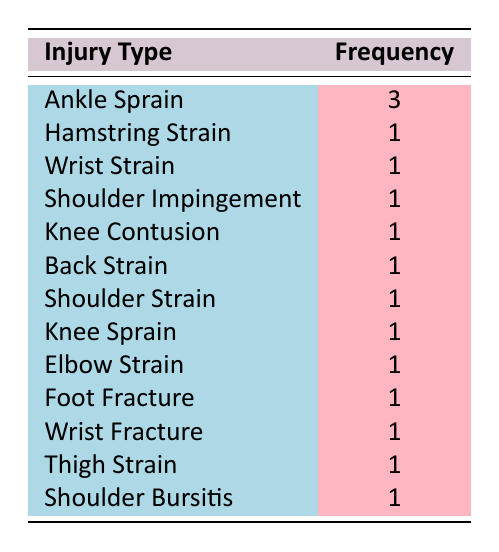What is the most frequent type of injury listed in the table? The table lists several injury types along with their frequencies. The injury type with the highest frequency is "Ankle Sprain," which appears 3 times.
Answer: Ankle Sprain How many different types of injuries are recorded in the table? By counting the distinct injury types listed in the table, we find there are 13 different types: Ankle Sprain, Hamstring Strain, Wrist Strain, Shoulder Impingement, Knee Contusion, Back Strain, Shoulder Strain, Knee Sprain, Elbow Strain, Foot Fracture, Wrist Fracture, Thigh Strain, and Shoulder Bursitis.
Answer: 13 Is there an injury type that occurred only once during the training sessions? The table shows multiple injury types, and when we check their frequencies, we see that Hamstring Strain, Wrist Strain, Shoulder Impingement, Knee Contusion, Back Strain, Shoulder Strain, Knee Sprain, Elbow Strain, Foot Fracture, Wrist Fracture, Thigh Strain, and Shoulder Bursitis each occurred once. Thus, the answer is yes.
Answer: Yes What is the total number of injuries recorded? To find the total number of injuries, we sum all the frequencies in the table. "Ankle Sprain" (3) + "Hamstring Strain" (1) + "Wrist Strain" (1) + "Shoulder Impingement" (1) + "Knee Contusion" (1) + "Back Strain" (1) + "Shoulder Strain" (1) + "Knee Sprain" (1) + "Elbow Strain" (1) + "Foot Fracture" (1) + "Wrist Fracture" (1) + "Thigh Strain" (1) + "Shoulder Bursitis" (1) = 15 injuries total.
Answer: 15 What percentage of the total injuries were ankle sprains? From the previous answer, we know the total number of injuries is 15. The frequency of ankle sprains is 3. To find the percentage, we calculate (3/15)*100 = 20%. Thus, ankle sprains account for 20% of total injuries.
Answer: 20% 